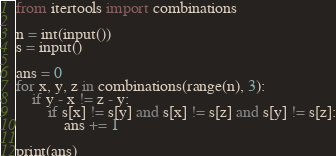<code> <loc_0><loc_0><loc_500><loc_500><_Python_>from itertools import combinations

n = int(input())
s = input()

ans = 0
for x, y, z in combinations(range(n), 3):
    if y - x != z - y:
        if s[x] != s[y] and s[x] != s[z] and s[y] != s[z]:
            ans += 1

print(ans)</code> 